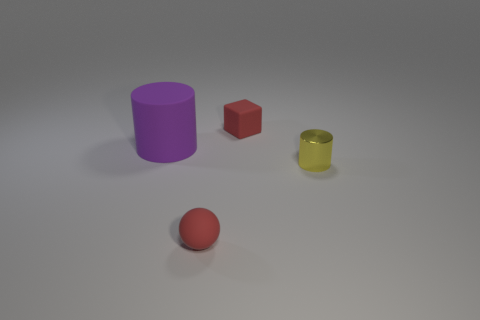What material is the small red cube?
Provide a short and direct response. Rubber. There is a thing that is the same color as the tiny sphere; what size is it?
Provide a short and direct response. Small. Does the yellow object have the same shape as the small red rubber thing in front of the small matte block?
Ensure brevity in your answer.  No. There is a cylinder in front of the rubber object that is left of the object that is in front of the small metallic thing; what is its material?
Ensure brevity in your answer.  Metal. What number of brown metal blocks are there?
Your answer should be very brief. 0. What number of cyan objects are large rubber things or small metallic things?
Offer a very short reply. 0. How many other objects are there of the same shape as the yellow metallic object?
Your response must be concise. 1. Do the tiny matte thing that is in front of the large rubber cylinder and the tiny thing behind the small yellow thing have the same color?
Give a very brief answer. Yes. How many tiny things are red things or cyan spheres?
Your response must be concise. 2. The yellow metallic object that is the same shape as the big rubber object is what size?
Your answer should be compact. Small. 